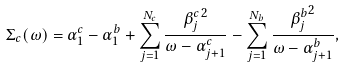Convert formula to latex. <formula><loc_0><loc_0><loc_500><loc_500>\Sigma _ { c } ( \omega ) = \alpha _ { 1 } ^ { c } - \alpha _ { 1 } ^ { b } + \sum _ { j = 1 } ^ { N _ { c } } \frac { { \beta _ { j } ^ { c } } ^ { 2 } } { \omega - \alpha _ { j + 1 } ^ { c } } - \sum _ { j = 1 } ^ { N _ { b } } \frac { { \beta _ { j } ^ { b } } ^ { 2 } } { \omega - \alpha _ { j + 1 } ^ { b } } ,</formula> 